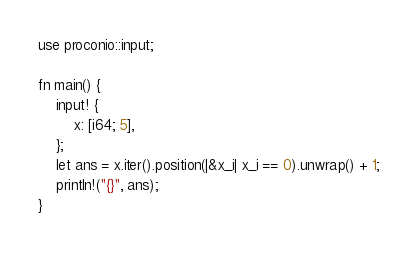Convert code to text. <code><loc_0><loc_0><loc_500><loc_500><_Rust_>use proconio::input;

fn main() {
    input! {
        x: [i64; 5],
    };
    let ans = x.iter().position(|&x_i| x_i == 0).unwrap() + 1;
    println!("{}", ans);
}
</code> 